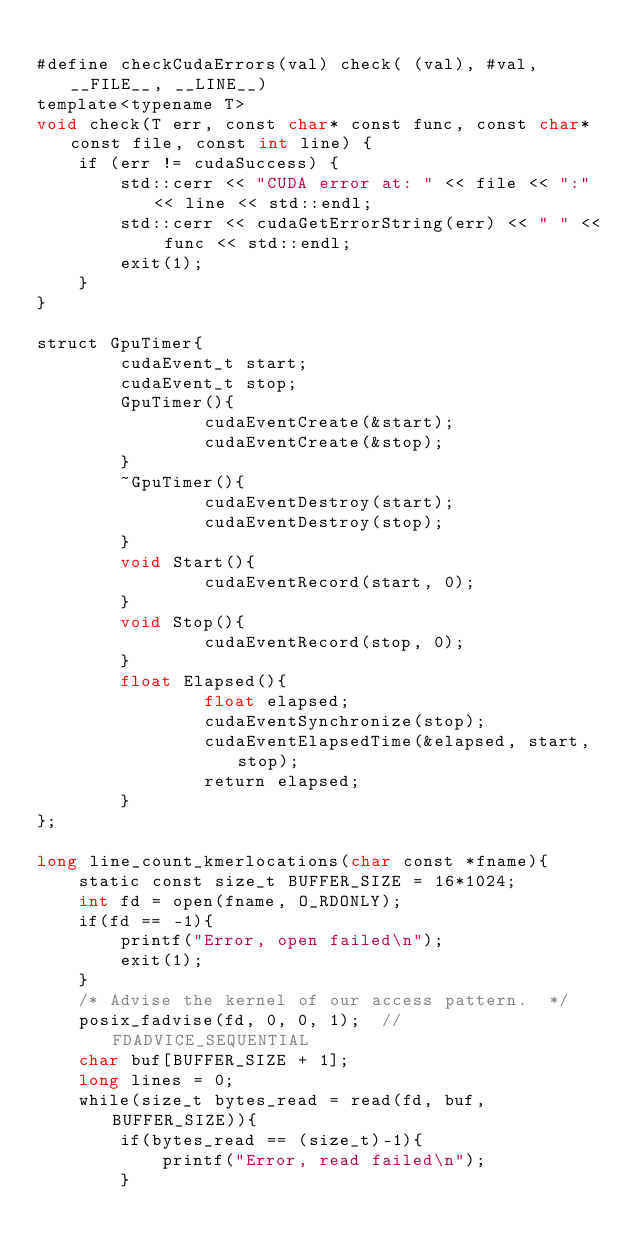Convert code to text. <code><loc_0><loc_0><loc_500><loc_500><_Cuda_>
#define checkCudaErrors(val) check( (val), #val, __FILE__, __LINE__)
template<typename T>
void check(T err, const char* const func, const char* const file, const int line) {
    if (err != cudaSuccess) {
        std::cerr << "CUDA error at: " << file << ":" << line << std::endl;
        std::cerr << cudaGetErrorString(err) << " " << func << std::endl;
        exit(1);
    }
}

struct GpuTimer{
        cudaEvent_t start;
        cudaEvent_t stop;
        GpuTimer(){
                cudaEventCreate(&start);
                cudaEventCreate(&stop);
        }
        ~GpuTimer(){
                cudaEventDestroy(start);
                cudaEventDestroy(stop);
        }
        void Start(){
                cudaEventRecord(start, 0);
        }
        void Stop(){
                cudaEventRecord(stop, 0);
        }
        float Elapsed(){
                float elapsed;
                cudaEventSynchronize(stop);
                cudaEventElapsedTime(&elapsed, start, stop);
                return elapsed;
        }
};

long line_count_kmerlocations(char const *fname){
    static const size_t BUFFER_SIZE = 16*1024;
    int fd = open(fname, O_RDONLY);
    if(fd == -1){
        printf("Error, open failed\n");
        exit(1);  
    }
    /* Advise the kernel of our access pattern.  */
    posix_fadvise(fd, 0, 0, 1);  // FDADVICE_SEQUENTIAL
    char buf[BUFFER_SIZE + 1];
    long lines = 0;
    while(size_t bytes_read = read(fd, buf, BUFFER_SIZE)){
        if(bytes_read == (size_t)-1){
            printf("Error, read failed\n");
        }</code> 